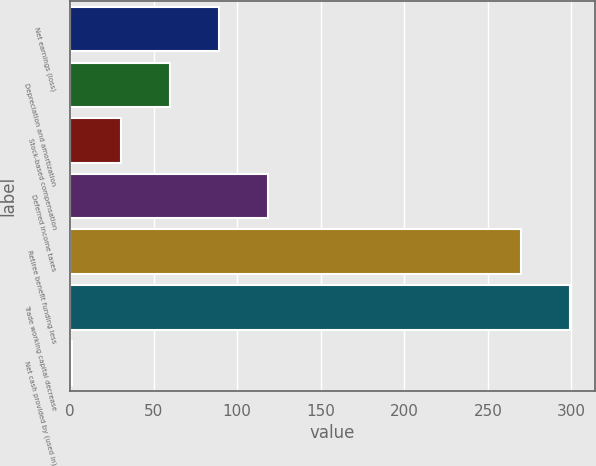Convert chart to OTSL. <chart><loc_0><loc_0><loc_500><loc_500><bar_chart><fcel>Net earnings (loss)<fcel>Depreciation and amortization<fcel>Stock-based compensation<fcel>Deferred income taxes<fcel>Retiree benefit funding less<fcel>Trade working capital decrease<fcel>Net cash provided by (used in)<nl><fcel>89.2<fcel>59.8<fcel>30.4<fcel>118.6<fcel>270<fcel>299.4<fcel>1<nl></chart> 